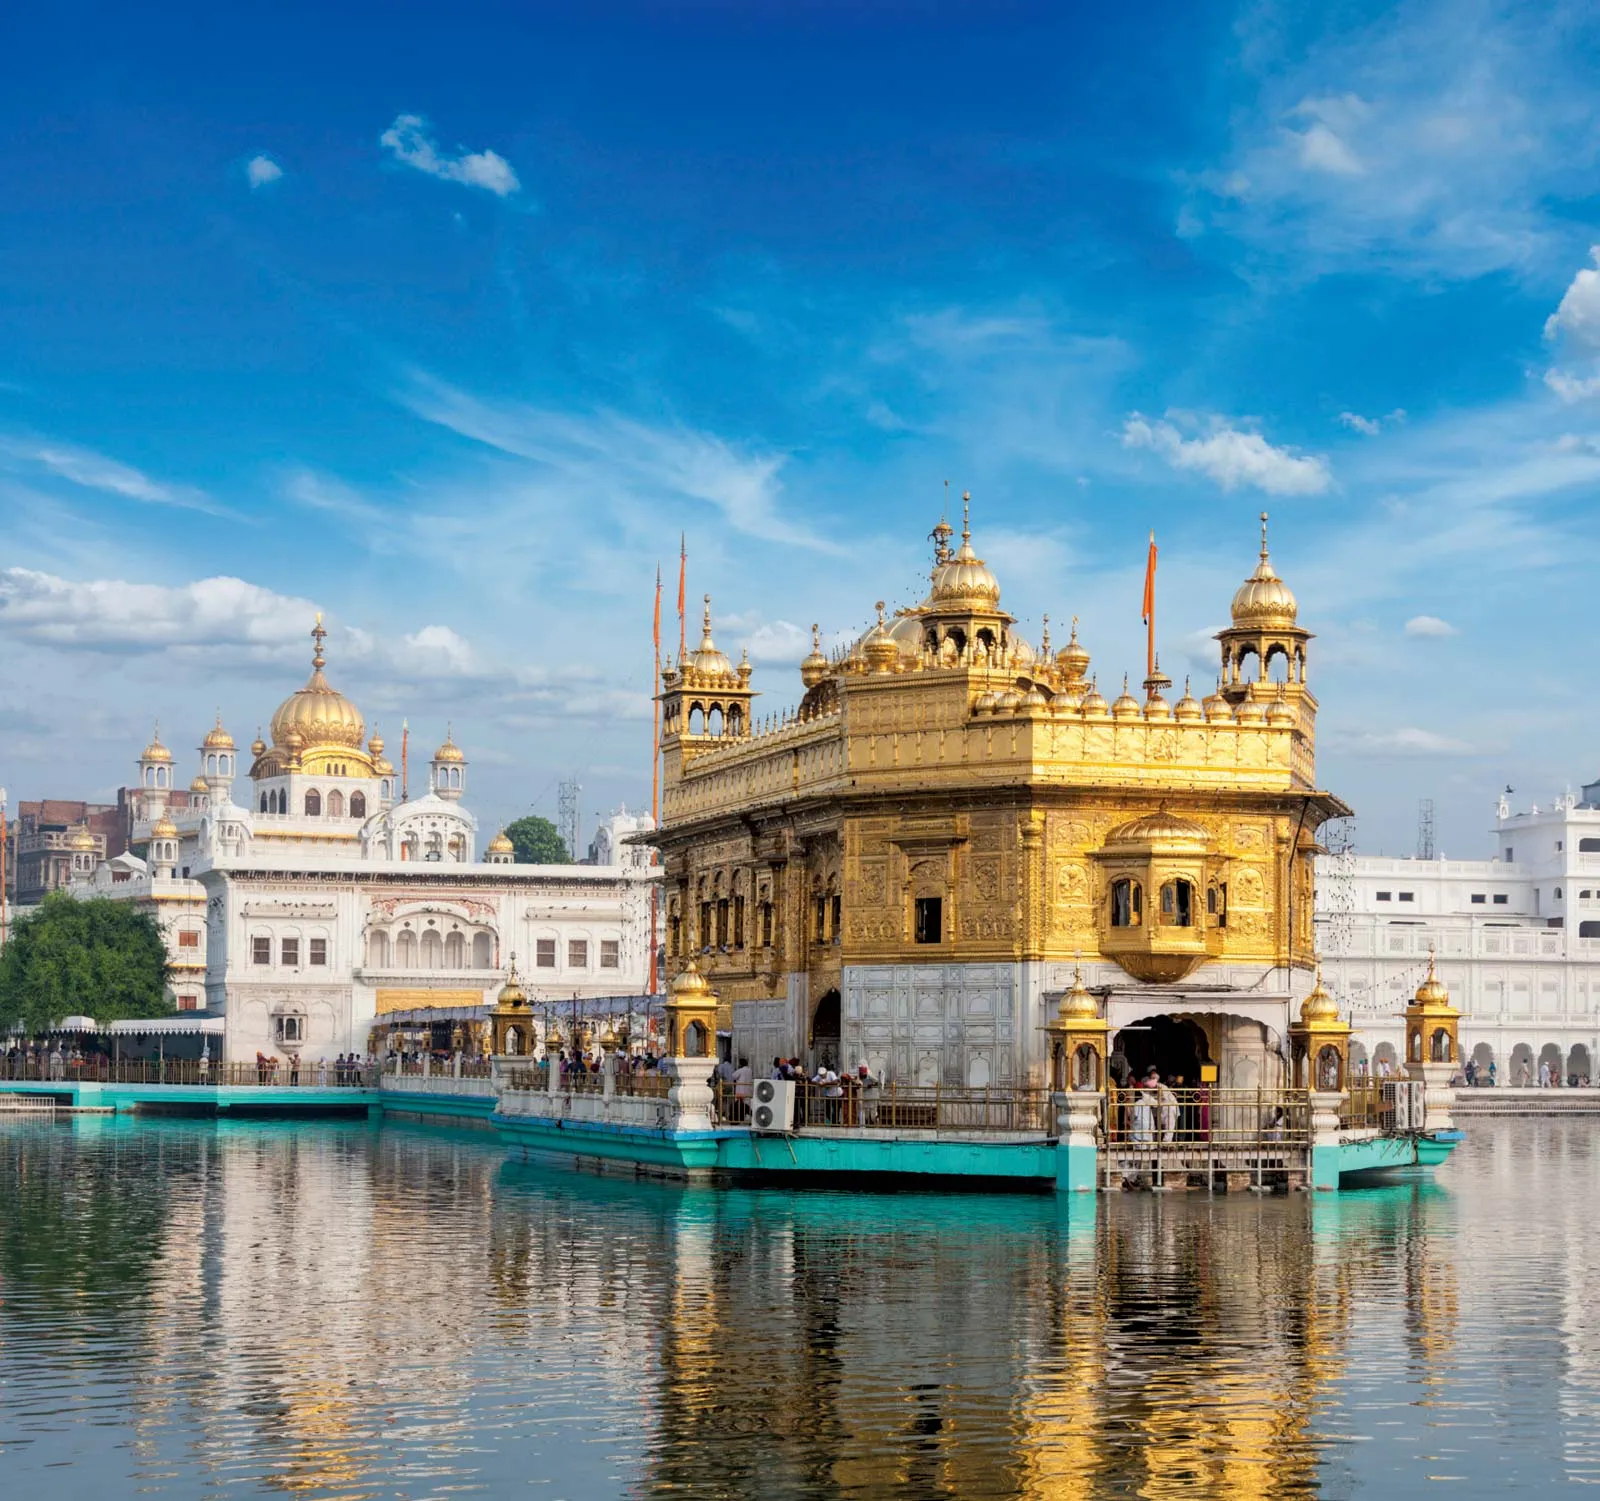What are some notable historical facts about the Golden Temple? The Golden Temple, also known as Harmandir Sahib, was founded by the fourth Sikh Guru, Guru Ram Das, in 1577. It was later completed by his successor, Guru Arjan, in 1604. The temple has been a place of great historical significance for Sikhs. During the 18th century, it faced numerous attacks but was repeatedly rebuilt by the Sikh community. One of the most notable events in its history was the installation of the Adi Granth, the holy scripture of Sikhism, inside the temple. The gold plating of the dome was later done under the patronage of Maharaja Ranjit Singh in the early 19th century. The Golden Temple symbolizes the synthesis of various cultural and artistic styles, exemplifying the rich heritage of Sikhism. Can you describe the architectural style and features of the Golden Temple in more detail? The architectural style of the Golden Temple is an exquisite blend of Hindu and Islamic influences, reflecting a harmonious amalgamation of cultural elements. The temple features a square plan with entrances on all four sides, symbolizing openness and acceptance towards people of all faiths. The lower part of the temple is constructed from white marble, intricately carved with floral designs, while the upper part is coated in gold leaf, which adds to its resplendence. The central dome is inspired by the lotus flower, which is a motif commonly found in Hindu architecture. Surrounding the main sanctum is the Amrit Sarovar, a holy pool that not only provides a reflective quality but also symbolizes spiritual purification. The parikrama or walkway around the pool allows devotees to perform a circumambulation, enhancing the spiritual experience. The intricate inlay work, jali (lattice) window designs, and the grand gateway, Darshani Deori, all contribute to the architectural magnificence of the Golden Temple. Imagine if the Golden Temple could speak. What stories would it tell us about the people and events it's witnessed over the centuries? If the Golden Temple could speak, it would tell tales of devotion, resilience, and harmony. It would recount the early days when Guru Arjan meticulously supervised its construction, infusing the sanctum with spiritual energy. The temple has witnessed countless pilgrims coming from far and wide, seeking solace and blessings. It would narrate the turbulent times during the 18th century when it was attacked by invaders, only to be rebuilt each time by the undeterred Sikh community. The Golden Temple would share stories of the spiritual fervor when the Adi Granth was ceremoniously installed, and how the sacred hymns have continuously echoed within its walls. It would also talk about the modernization efforts that have preserved its splendor, ensuring that each generation can witness its glory. Through its reflection in the Amrit Sarovar, the temple has silently observed moments of joy, sorrow, and unwavering faith, standing as a beacon of spiritual unity and peace. 